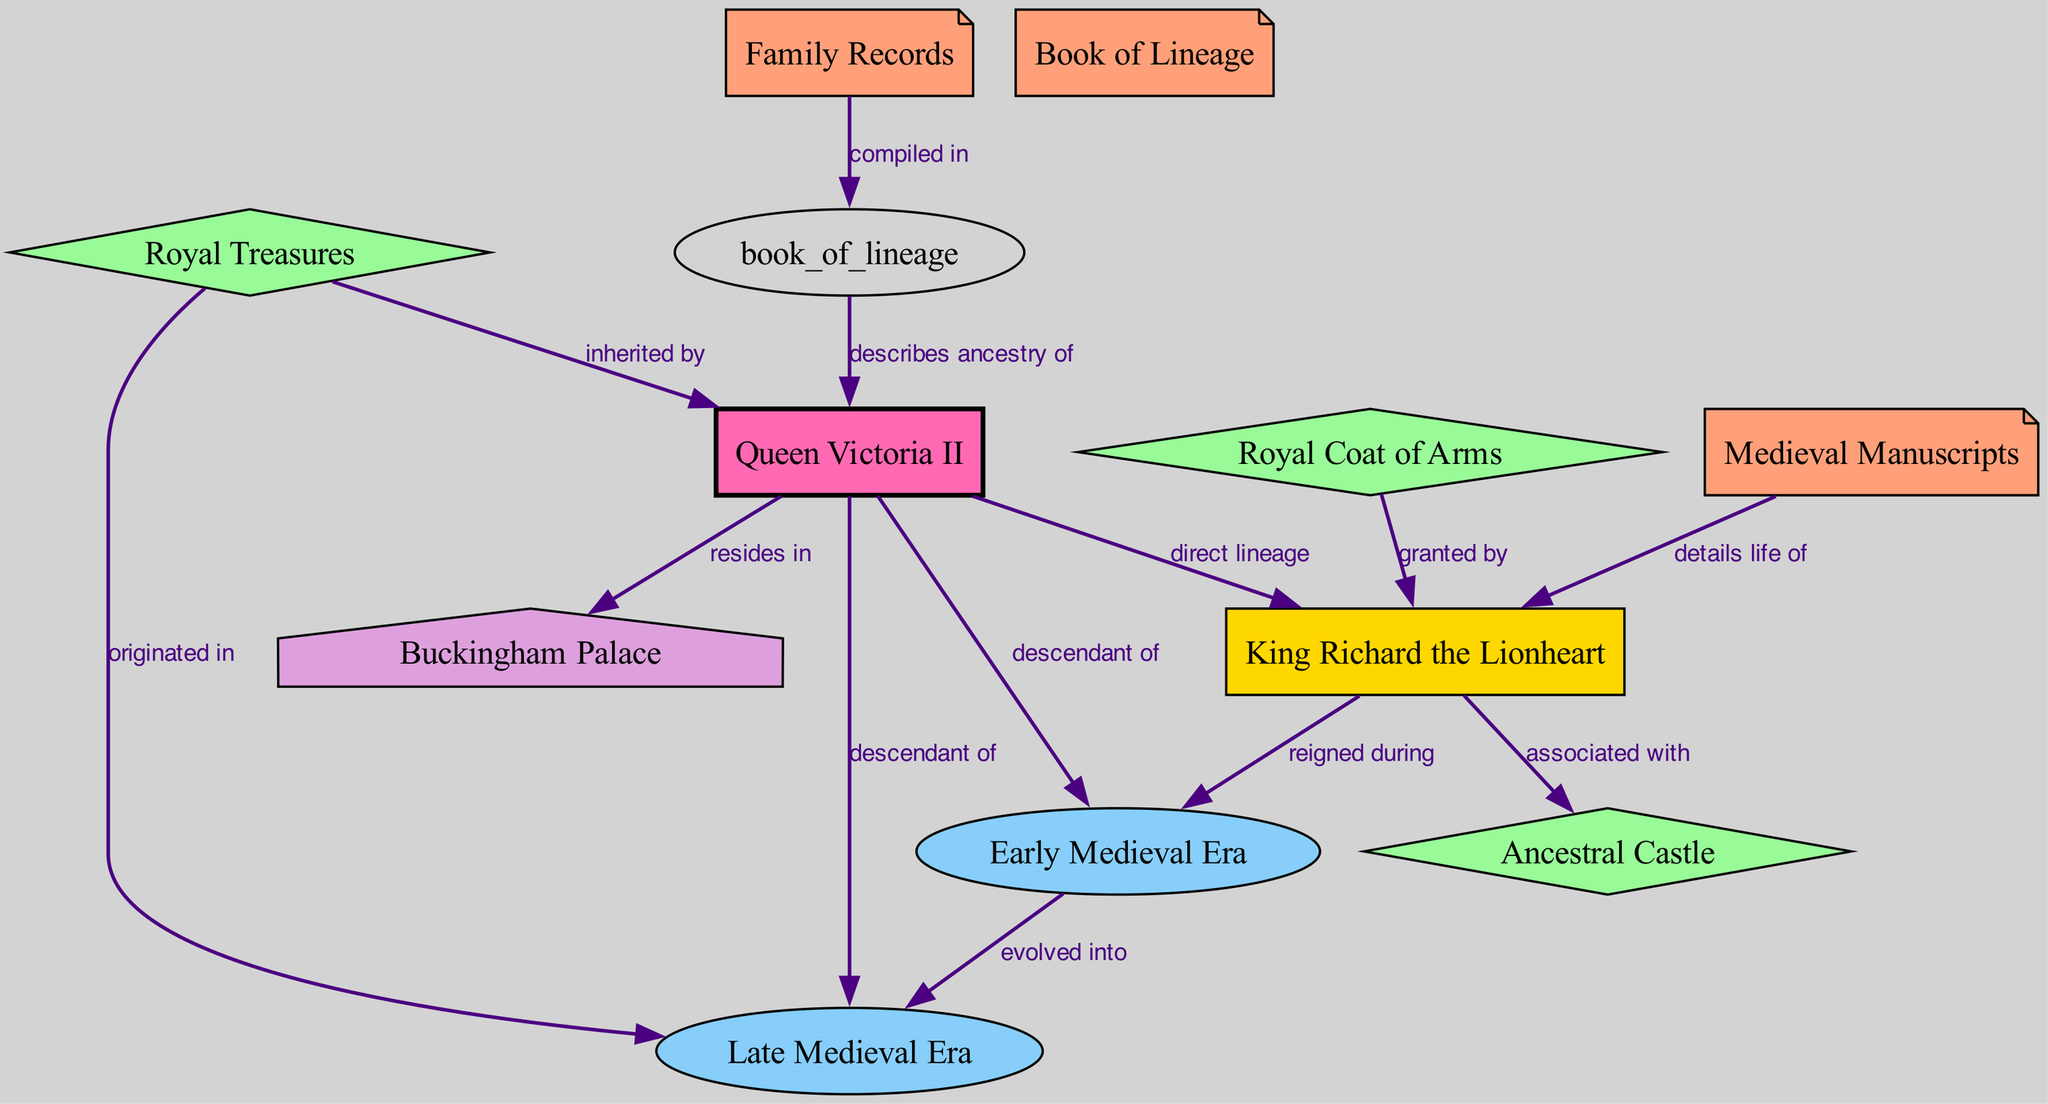What medieval monarch is highlighted in the diagram? The diagram prominently features King Richard the Lionheart as the notable medieval monarch, indicated as a key figure to represent the lineage.
Answer: King Richard the Lionheart Which historical period did King Richard the Lionheart reign during? The diagram shows a direct edge labeled "reigned during" connecting King Richard the Lionheart to the Early Medieval Era, establishing this period as his reign.
Answer: Early Medieval Era What current royal figure is a descendant of King Richard the Lionheart? The diagram indicates that Queen Victoria II, shown as a modern royal family head, is a descendant of King Richard the Lionheart through edges marked "descendant of."
Answer: Queen Victoria II How many documents are listed in the diagram? The diagram identifies three distinct documents: Medieval Manuscripts, Family Records, and Book of Lineage, thus providing a count of the documents present.
Answer: 3 What artifact is associated with King Richard the Lionheart? The edge labeled "associated with" points directly from the medieval monarch to Ancestral Castle, indicating this artifact as being linked to King Richard the Lionheart.
Answer: Ancestral Castle Which document describes the ancestry of the modern royal family head? The edge labeled "describes ancestry of" leads from the Book of Lineage to Queen Victoria II, indicating that this document provides details about her ancestry.
Answer: Book of Lineage What type of artifact originated in the Late Medieval Era? The label "originated in" connects Royal Treasures to the Late Medieval Era, establishing that these treasures were first introduced during this period.
Answer: Royal Treasures Which current landmark is associated with the modern royal family head? The diagram illustrates a connection from Queen Victoria II to Buckingham Palace, marked as "resides in," indicating this current landmark is tied to her.
Answer: Buckingham Palace How did Royal Treasures enter the possession of the modern royal family head? The edge labeled "inherited by" shows Royal Treasures being passed down to Queen Victoria II, confirming this line of inheritance.
Answer: Inherited by 